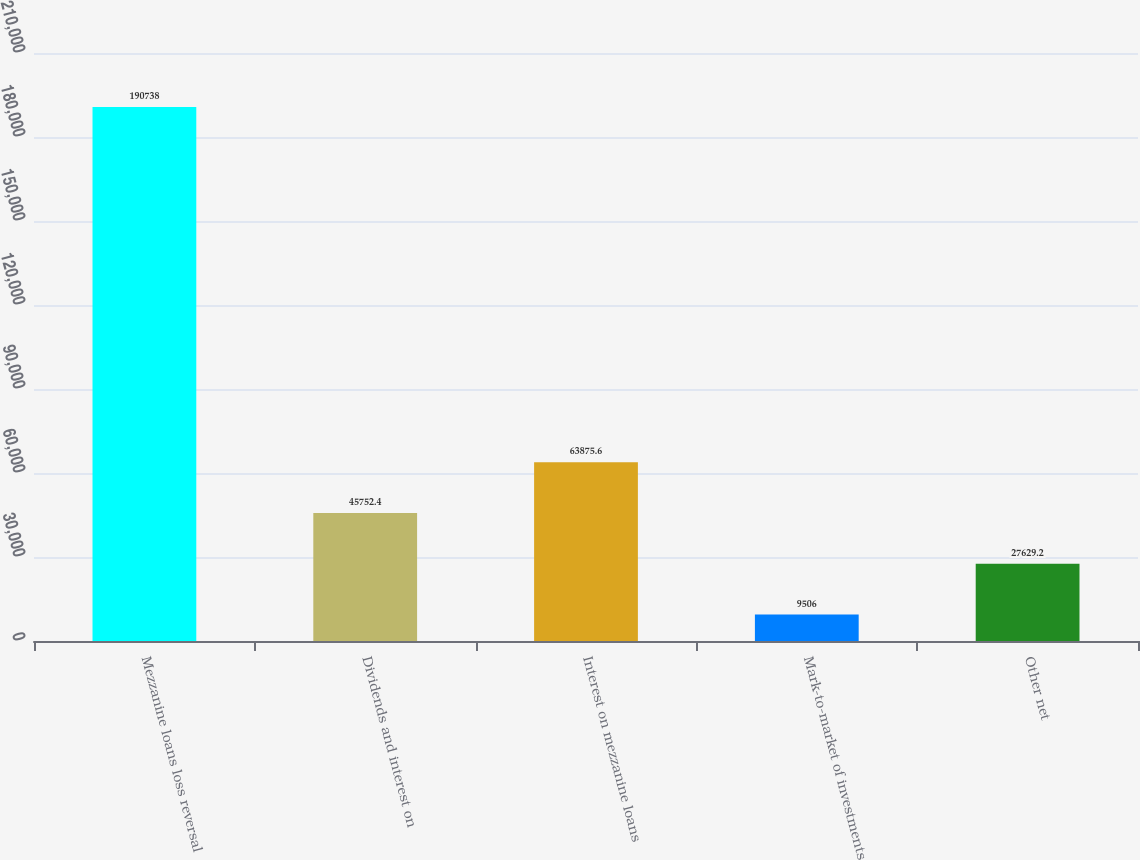Convert chart. <chart><loc_0><loc_0><loc_500><loc_500><bar_chart><fcel>Mezzanine loans loss reversal<fcel>Dividends and interest on<fcel>Interest on mezzanine loans<fcel>Mark-to-market of investments<fcel>Other net<nl><fcel>190738<fcel>45752.4<fcel>63875.6<fcel>9506<fcel>27629.2<nl></chart> 